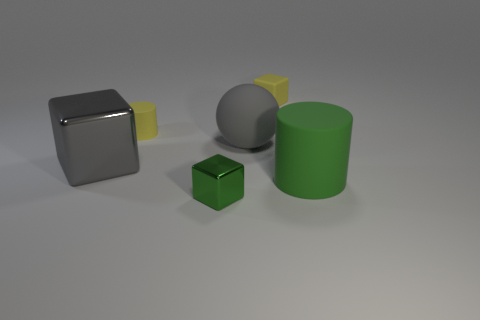How many blue cylinders have the same material as the small yellow block?
Make the answer very short. 0. What number of matte things are green objects or tiny spheres?
Keep it short and to the point. 1. Do the gray object that is to the left of the big gray matte object and the yellow object that is right of the tiny metallic object have the same shape?
Keep it short and to the point. Yes. There is a block that is on the right side of the tiny cylinder and in front of the yellow rubber cylinder; what is its color?
Offer a very short reply. Green. There is a green object to the right of the tiny yellow rubber block; is it the same size as the cylinder on the left side of the large gray rubber sphere?
Your answer should be compact. No. What number of large things have the same color as the large ball?
Your response must be concise. 1. What number of large things are spheres or yellow shiny blocks?
Your answer should be compact. 1. Does the tiny yellow object right of the tiny green object have the same material as the green cube?
Offer a terse response. No. There is a large matte thing behind the green rubber thing; what color is it?
Offer a terse response. Gray. Is the number of blue things the same as the number of green shiny things?
Ensure brevity in your answer.  No. 